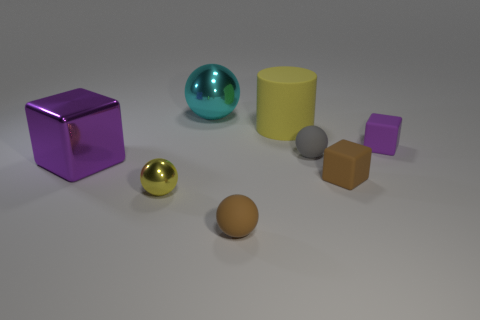Are there any small rubber spheres in front of the yellow object behind the small thing that is to the left of the big cyan ball?
Ensure brevity in your answer.  Yes. What number of other things are the same shape as the large purple metal thing?
Keep it short and to the point. 2. What is the shape of the metal thing that is both in front of the large cylinder and behind the brown matte cube?
Your answer should be compact. Cube. What color is the metallic ball that is in front of the purple cube in front of the rubber ball behind the brown rubber block?
Your answer should be compact. Yellow. Are there more blocks that are behind the big yellow object than tiny metal objects that are to the right of the small purple matte block?
Your response must be concise. No. How many other things are there of the same size as the purple rubber thing?
Your response must be concise. 4. The ball that is the same color as the big cylinder is what size?
Offer a very short reply. Small. There is a purple object that is to the right of the purple object that is in front of the purple matte cube; what is its material?
Provide a short and direct response. Rubber. Are there any purple objects in front of the tiny brown matte sphere?
Provide a succinct answer. No. Are there more tiny brown matte spheres that are behind the tiny metal thing than purple metallic objects?
Make the answer very short. No. 